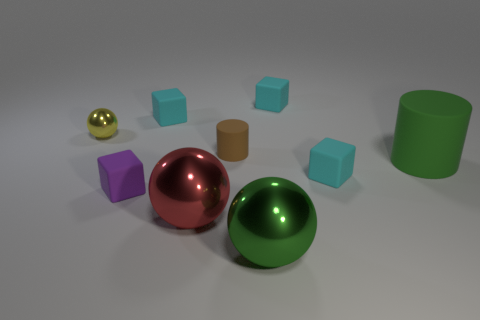Can you describe the texture differences between the objects? Certainly. The spheres and the cylinder exhibit smooth, reflective textures suggesting they are made of materials like polished metal or plastic. In contrast, the matte cube objects have a rougher appearance, which could imply a material like unpolished stone or matte plastic that does not reflect light as sharply. 